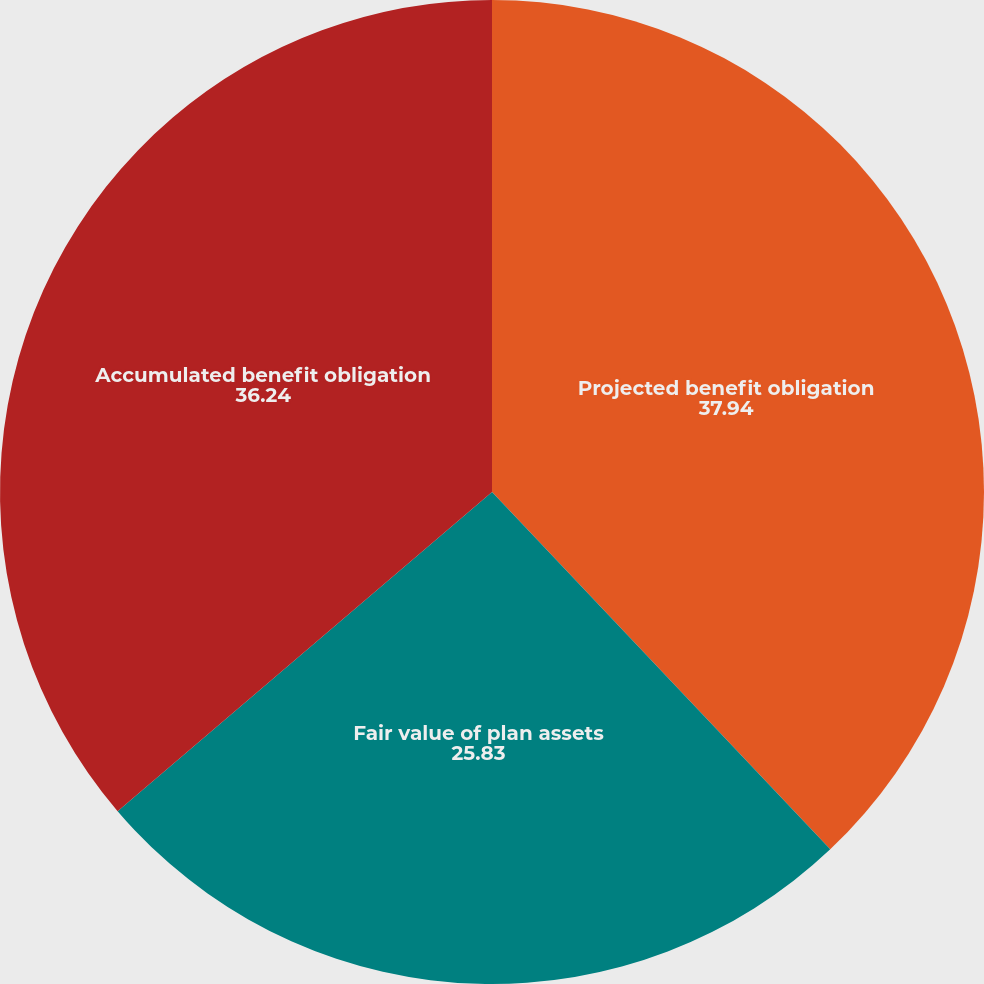Convert chart. <chart><loc_0><loc_0><loc_500><loc_500><pie_chart><fcel>Projected benefit obligation<fcel>Fair value of plan assets<fcel>Accumulated benefit obligation<nl><fcel>37.94%<fcel>25.83%<fcel>36.24%<nl></chart> 